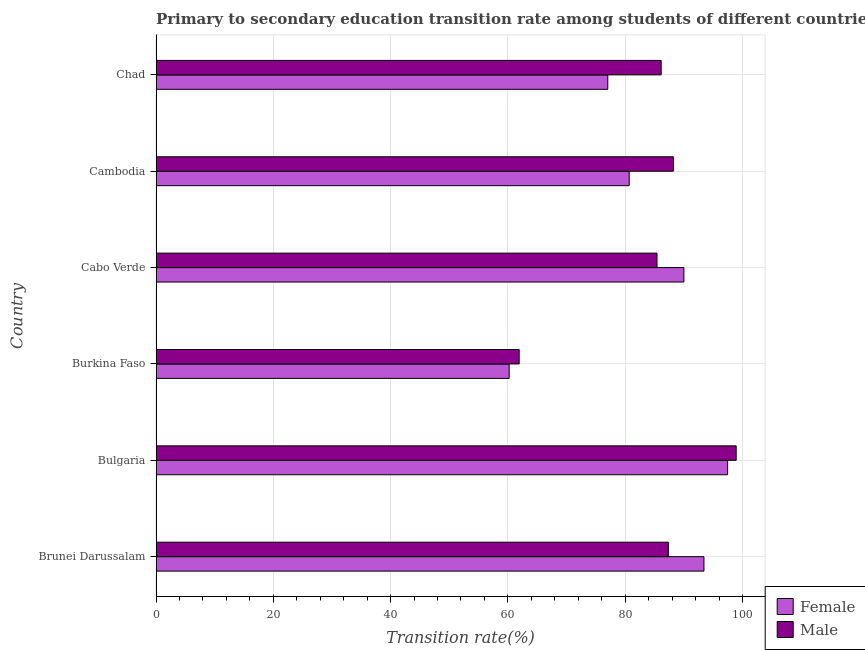What is the label of the 4th group of bars from the top?
Keep it short and to the point. Burkina Faso. In how many cases, is the number of bars for a given country not equal to the number of legend labels?
Keep it short and to the point. 0. What is the transition rate among female students in Cabo Verde?
Offer a terse response. 90.01. Across all countries, what is the maximum transition rate among male students?
Offer a terse response. 98.93. Across all countries, what is the minimum transition rate among female students?
Your answer should be very brief. 60.22. In which country was the transition rate among female students minimum?
Make the answer very short. Burkina Faso. What is the total transition rate among female students in the graph?
Ensure brevity in your answer.  498.86. What is the difference between the transition rate among male students in Brunei Darussalam and that in Chad?
Make the answer very short. 1.23. What is the difference between the transition rate among male students in Chad and the transition rate among female students in Cambodia?
Offer a very short reply. 5.45. What is the average transition rate among female students per country?
Offer a terse response. 83.14. What is the difference between the transition rate among male students and transition rate among female students in Brunei Darussalam?
Your answer should be compact. -6.07. In how many countries, is the transition rate among male students greater than 56 %?
Your response must be concise. 6. What is the difference between the highest and the second highest transition rate among female students?
Ensure brevity in your answer.  4.03. What is the difference between the highest and the lowest transition rate among male students?
Offer a terse response. 37.01. How many bars are there?
Provide a succinct answer. 12. Are all the bars in the graph horizontal?
Your answer should be compact. Yes. How many countries are there in the graph?
Provide a short and direct response. 6. What is the difference between two consecutive major ticks on the X-axis?
Keep it short and to the point. 20. Where does the legend appear in the graph?
Offer a terse response. Bottom right. How many legend labels are there?
Ensure brevity in your answer.  2. What is the title of the graph?
Make the answer very short. Primary to secondary education transition rate among students of different countries. What is the label or title of the X-axis?
Keep it short and to the point. Transition rate(%). What is the label or title of the Y-axis?
Ensure brevity in your answer.  Country. What is the Transition rate(%) in Female in Brunei Darussalam?
Your answer should be very brief. 93.44. What is the Transition rate(%) in Male in Brunei Darussalam?
Offer a terse response. 87.37. What is the Transition rate(%) in Female in Bulgaria?
Make the answer very short. 97.47. What is the Transition rate(%) in Male in Bulgaria?
Give a very brief answer. 98.93. What is the Transition rate(%) of Female in Burkina Faso?
Keep it short and to the point. 60.22. What is the Transition rate(%) in Male in Burkina Faso?
Make the answer very short. 61.93. What is the Transition rate(%) in Female in Cabo Verde?
Your response must be concise. 90.01. What is the Transition rate(%) in Male in Cabo Verde?
Ensure brevity in your answer.  85.43. What is the Transition rate(%) of Female in Cambodia?
Provide a short and direct response. 80.69. What is the Transition rate(%) in Male in Cambodia?
Keep it short and to the point. 88.23. What is the Transition rate(%) in Female in Chad?
Ensure brevity in your answer.  77.03. What is the Transition rate(%) in Male in Chad?
Ensure brevity in your answer.  86.14. Across all countries, what is the maximum Transition rate(%) of Female?
Ensure brevity in your answer.  97.47. Across all countries, what is the maximum Transition rate(%) of Male?
Your answer should be very brief. 98.93. Across all countries, what is the minimum Transition rate(%) of Female?
Make the answer very short. 60.22. Across all countries, what is the minimum Transition rate(%) in Male?
Your answer should be compact. 61.93. What is the total Transition rate(%) in Female in the graph?
Make the answer very short. 498.86. What is the total Transition rate(%) of Male in the graph?
Offer a terse response. 508.02. What is the difference between the Transition rate(%) of Female in Brunei Darussalam and that in Bulgaria?
Provide a succinct answer. -4.03. What is the difference between the Transition rate(%) of Male in Brunei Darussalam and that in Bulgaria?
Your response must be concise. -11.57. What is the difference between the Transition rate(%) of Female in Brunei Darussalam and that in Burkina Faso?
Provide a succinct answer. 33.22. What is the difference between the Transition rate(%) in Male in Brunei Darussalam and that in Burkina Faso?
Give a very brief answer. 25.44. What is the difference between the Transition rate(%) of Female in Brunei Darussalam and that in Cabo Verde?
Provide a short and direct response. 3.42. What is the difference between the Transition rate(%) of Male in Brunei Darussalam and that in Cabo Verde?
Provide a short and direct response. 1.94. What is the difference between the Transition rate(%) of Female in Brunei Darussalam and that in Cambodia?
Offer a terse response. 12.74. What is the difference between the Transition rate(%) of Male in Brunei Darussalam and that in Cambodia?
Give a very brief answer. -0.86. What is the difference between the Transition rate(%) in Female in Brunei Darussalam and that in Chad?
Provide a succinct answer. 16.4. What is the difference between the Transition rate(%) in Male in Brunei Darussalam and that in Chad?
Ensure brevity in your answer.  1.23. What is the difference between the Transition rate(%) in Female in Bulgaria and that in Burkina Faso?
Your answer should be very brief. 37.25. What is the difference between the Transition rate(%) in Male in Bulgaria and that in Burkina Faso?
Give a very brief answer. 37.01. What is the difference between the Transition rate(%) in Female in Bulgaria and that in Cabo Verde?
Keep it short and to the point. 7.46. What is the difference between the Transition rate(%) of Male in Bulgaria and that in Cabo Verde?
Offer a very short reply. 13.5. What is the difference between the Transition rate(%) of Female in Bulgaria and that in Cambodia?
Provide a succinct answer. 16.78. What is the difference between the Transition rate(%) of Male in Bulgaria and that in Cambodia?
Ensure brevity in your answer.  10.7. What is the difference between the Transition rate(%) in Female in Bulgaria and that in Chad?
Ensure brevity in your answer.  20.43. What is the difference between the Transition rate(%) in Male in Bulgaria and that in Chad?
Make the answer very short. 12.79. What is the difference between the Transition rate(%) in Female in Burkina Faso and that in Cabo Verde?
Offer a very short reply. -29.79. What is the difference between the Transition rate(%) of Male in Burkina Faso and that in Cabo Verde?
Provide a succinct answer. -23.5. What is the difference between the Transition rate(%) of Female in Burkina Faso and that in Cambodia?
Make the answer very short. -20.47. What is the difference between the Transition rate(%) of Male in Burkina Faso and that in Cambodia?
Offer a very short reply. -26.3. What is the difference between the Transition rate(%) of Female in Burkina Faso and that in Chad?
Ensure brevity in your answer.  -16.82. What is the difference between the Transition rate(%) in Male in Burkina Faso and that in Chad?
Make the answer very short. -24.21. What is the difference between the Transition rate(%) in Female in Cabo Verde and that in Cambodia?
Your response must be concise. 9.32. What is the difference between the Transition rate(%) in Male in Cabo Verde and that in Cambodia?
Keep it short and to the point. -2.8. What is the difference between the Transition rate(%) of Female in Cabo Verde and that in Chad?
Your answer should be very brief. 12.98. What is the difference between the Transition rate(%) of Male in Cabo Verde and that in Chad?
Keep it short and to the point. -0.71. What is the difference between the Transition rate(%) in Female in Cambodia and that in Chad?
Your answer should be compact. 3.66. What is the difference between the Transition rate(%) of Male in Cambodia and that in Chad?
Provide a short and direct response. 2.09. What is the difference between the Transition rate(%) in Female in Brunei Darussalam and the Transition rate(%) in Male in Bulgaria?
Give a very brief answer. -5.5. What is the difference between the Transition rate(%) of Female in Brunei Darussalam and the Transition rate(%) of Male in Burkina Faso?
Ensure brevity in your answer.  31.51. What is the difference between the Transition rate(%) of Female in Brunei Darussalam and the Transition rate(%) of Male in Cabo Verde?
Offer a very short reply. 8.01. What is the difference between the Transition rate(%) in Female in Brunei Darussalam and the Transition rate(%) in Male in Cambodia?
Your answer should be compact. 5.21. What is the difference between the Transition rate(%) in Female in Brunei Darussalam and the Transition rate(%) in Male in Chad?
Offer a very short reply. 7.3. What is the difference between the Transition rate(%) in Female in Bulgaria and the Transition rate(%) in Male in Burkina Faso?
Offer a terse response. 35.54. What is the difference between the Transition rate(%) in Female in Bulgaria and the Transition rate(%) in Male in Cabo Verde?
Give a very brief answer. 12.04. What is the difference between the Transition rate(%) in Female in Bulgaria and the Transition rate(%) in Male in Cambodia?
Provide a succinct answer. 9.24. What is the difference between the Transition rate(%) in Female in Bulgaria and the Transition rate(%) in Male in Chad?
Give a very brief answer. 11.33. What is the difference between the Transition rate(%) in Female in Burkina Faso and the Transition rate(%) in Male in Cabo Verde?
Your response must be concise. -25.21. What is the difference between the Transition rate(%) in Female in Burkina Faso and the Transition rate(%) in Male in Cambodia?
Your answer should be compact. -28.01. What is the difference between the Transition rate(%) of Female in Burkina Faso and the Transition rate(%) of Male in Chad?
Provide a succinct answer. -25.92. What is the difference between the Transition rate(%) in Female in Cabo Verde and the Transition rate(%) in Male in Cambodia?
Provide a succinct answer. 1.78. What is the difference between the Transition rate(%) in Female in Cabo Verde and the Transition rate(%) in Male in Chad?
Your answer should be compact. 3.87. What is the difference between the Transition rate(%) in Female in Cambodia and the Transition rate(%) in Male in Chad?
Offer a very short reply. -5.45. What is the average Transition rate(%) in Female per country?
Keep it short and to the point. 83.14. What is the average Transition rate(%) of Male per country?
Your response must be concise. 84.67. What is the difference between the Transition rate(%) in Female and Transition rate(%) in Male in Brunei Darussalam?
Make the answer very short. 6.07. What is the difference between the Transition rate(%) in Female and Transition rate(%) in Male in Bulgaria?
Offer a terse response. -1.46. What is the difference between the Transition rate(%) of Female and Transition rate(%) of Male in Burkina Faso?
Offer a terse response. -1.71. What is the difference between the Transition rate(%) in Female and Transition rate(%) in Male in Cabo Verde?
Provide a succinct answer. 4.58. What is the difference between the Transition rate(%) in Female and Transition rate(%) in Male in Cambodia?
Make the answer very short. -7.54. What is the difference between the Transition rate(%) of Female and Transition rate(%) of Male in Chad?
Make the answer very short. -9.1. What is the ratio of the Transition rate(%) of Female in Brunei Darussalam to that in Bulgaria?
Provide a short and direct response. 0.96. What is the ratio of the Transition rate(%) in Male in Brunei Darussalam to that in Bulgaria?
Give a very brief answer. 0.88. What is the ratio of the Transition rate(%) of Female in Brunei Darussalam to that in Burkina Faso?
Offer a terse response. 1.55. What is the ratio of the Transition rate(%) of Male in Brunei Darussalam to that in Burkina Faso?
Give a very brief answer. 1.41. What is the ratio of the Transition rate(%) of Female in Brunei Darussalam to that in Cabo Verde?
Provide a succinct answer. 1.04. What is the ratio of the Transition rate(%) in Male in Brunei Darussalam to that in Cabo Verde?
Give a very brief answer. 1.02. What is the ratio of the Transition rate(%) of Female in Brunei Darussalam to that in Cambodia?
Your answer should be very brief. 1.16. What is the ratio of the Transition rate(%) of Male in Brunei Darussalam to that in Cambodia?
Make the answer very short. 0.99. What is the ratio of the Transition rate(%) of Female in Brunei Darussalam to that in Chad?
Your response must be concise. 1.21. What is the ratio of the Transition rate(%) in Male in Brunei Darussalam to that in Chad?
Provide a short and direct response. 1.01. What is the ratio of the Transition rate(%) of Female in Bulgaria to that in Burkina Faso?
Offer a terse response. 1.62. What is the ratio of the Transition rate(%) in Male in Bulgaria to that in Burkina Faso?
Your response must be concise. 1.6. What is the ratio of the Transition rate(%) of Female in Bulgaria to that in Cabo Verde?
Make the answer very short. 1.08. What is the ratio of the Transition rate(%) of Male in Bulgaria to that in Cabo Verde?
Keep it short and to the point. 1.16. What is the ratio of the Transition rate(%) in Female in Bulgaria to that in Cambodia?
Give a very brief answer. 1.21. What is the ratio of the Transition rate(%) in Male in Bulgaria to that in Cambodia?
Make the answer very short. 1.12. What is the ratio of the Transition rate(%) in Female in Bulgaria to that in Chad?
Give a very brief answer. 1.27. What is the ratio of the Transition rate(%) in Male in Bulgaria to that in Chad?
Offer a very short reply. 1.15. What is the ratio of the Transition rate(%) of Female in Burkina Faso to that in Cabo Verde?
Your response must be concise. 0.67. What is the ratio of the Transition rate(%) of Male in Burkina Faso to that in Cabo Verde?
Your response must be concise. 0.72. What is the ratio of the Transition rate(%) in Female in Burkina Faso to that in Cambodia?
Offer a terse response. 0.75. What is the ratio of the Transition rate(%) of Male in Burkina Faso to that in Cambodia?
Provide a short and direct response. 0.7. What is the ratio of the Transition rate(%) of Female in Burkina Faso to that in Chad?
Ensure brevity in your answer.  0.78. What is the ratio of the Transition rate(%) of Male in Burkina Faso to that in Chad?
Offer a very short reply. 0.72. What is the ratio of the Transition rate(%) of Female in Cabo Verde to that in Cambodia?
Provide a short and direct response. 1.12. What is the ratio of the Transition rate(%) of Male in Cabo Verde to that in Cambodia?
Provide a succinct answer. 0.97. What is the ratio of the Transition rate(%) in Female in Cabo Verde to that in Chad?
Ensure brevity in your answer.  1.17. What is the ratio of the Transition rate(%) of Male in Cabo Verde to that in Chad?
Your answer should be very brief. 0.99. What is the ratio of the Transition rate(%) in Female in Cambodia to that in Chad?
Your answer should be compact. 1.05. What is the ratio of the Transition rate(%) of Male in Cambodia to that in Chad?
Your answer should be very brief. 1.02. What is the difference between the highest and the second highest Transition rate(%) of Female?
Provide a succinct answer. 4.03. What is the difference between the highest and the second highest Transition rate(%) in Male?
Your response must be concise. 10.7. What is the difference between the highest and the lowest Transition rate(%) of Female?
Your response must be concise. 37.25. What is the difference between the highest and the lowest Transition rate(%) in Male?
Give a very brief answer. 37.01. 